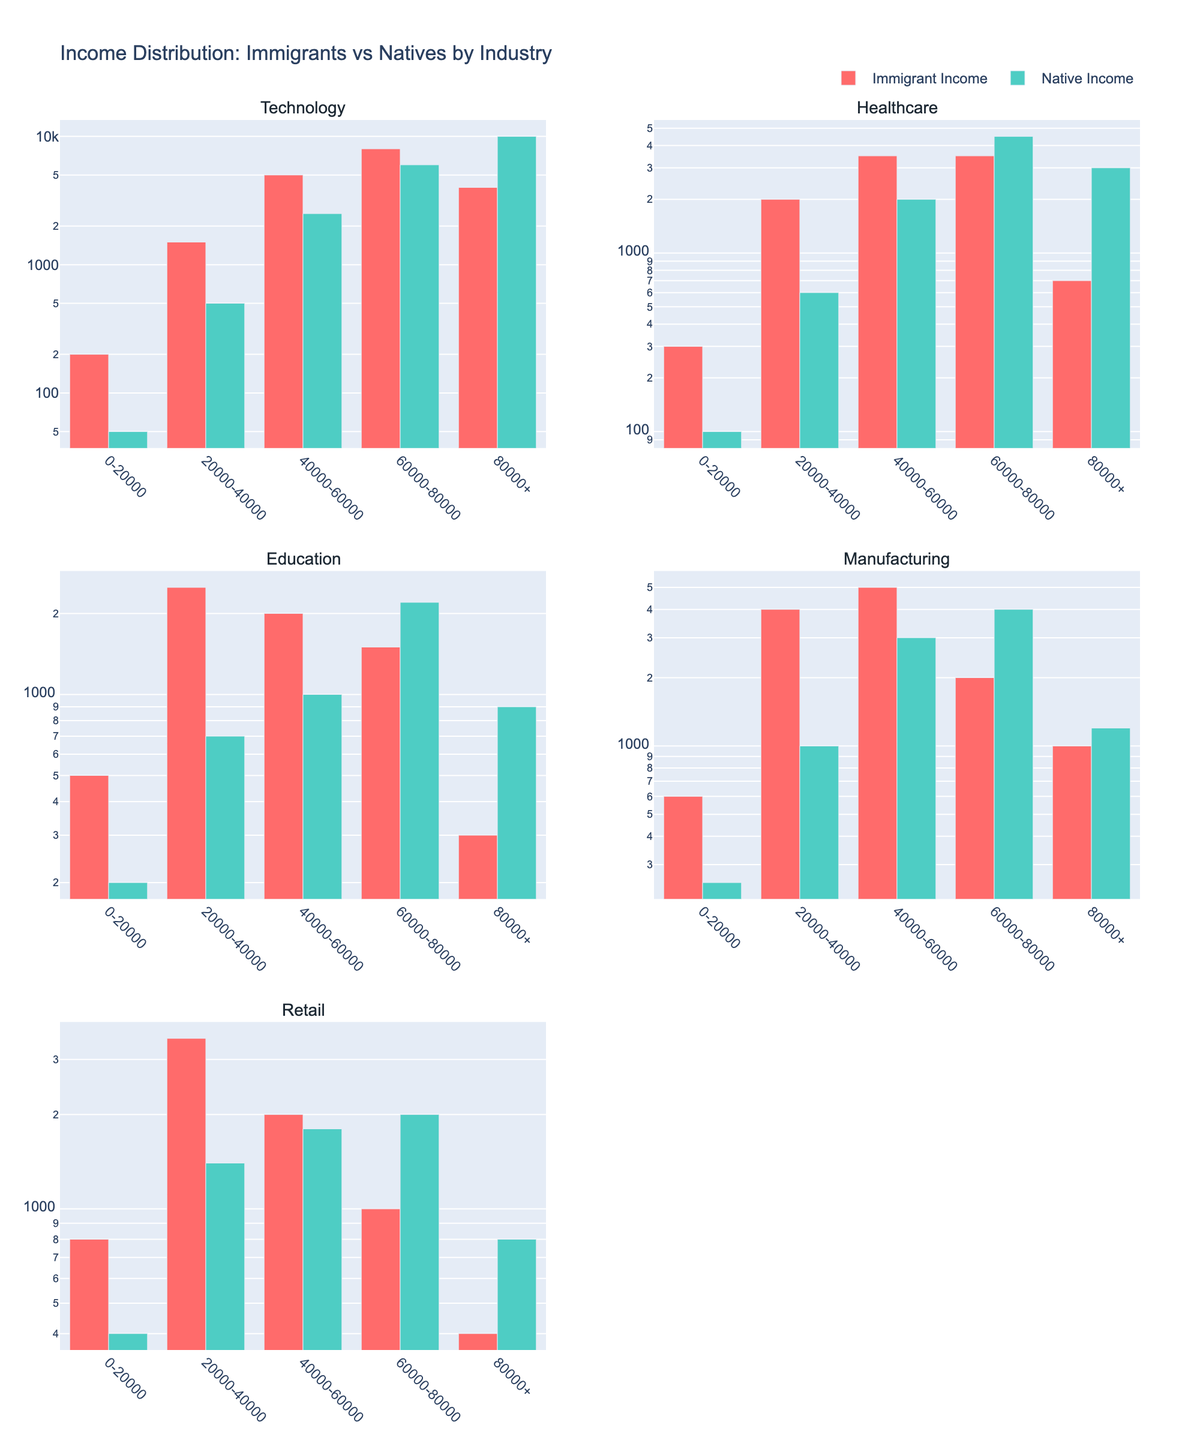What's the title of the figure? The title of the figure is located at the top-center of the plot. It reads "Income Distribution: Immigrants vs Natives by Industry", which is straightforward to find because of its prominent placement.
Answer: "Income Distribution: Immigrants vs Natives by Industry" How does the immigrant income compare to native income in the 80000+ segment for the Technology industry? The subplot for the Technology industry shows two bars for the 80000+ income segment. The bar for Immigrant Income is lower than the bar for Native Income. Specifically, the Immigrant Income is 4000, while the Native Income is 10000.
Answer: Immigrant Income is 4000, Native Income is 10000 What is the income segment with the highest income for immigrants in Healthcare, and how much is it? In the Healthcare subplot, check for the tallest bar in the Immigrant Income categories. The highest is the 20000-40000 segment, with an income of 2000.
Answer: 20000-40000 income segment, 2000 Which industry has the closest immigrant and native income distributions for the 0-20000 segment? By comparing the height of bars for Immigrant and Native Income in the 0-20000 segments across all subplots, you can see that Healthcare has the closest distribution with 300 vs 100 units.
Answer: Healthcare What is the difference between immigrant and native incomes in the 60000-80000 segment of the Retail industry? Check the heights of the two bars for the 60000-80000 segment in the Retail industry subplot. The bars for Immigrant Income and Native Income are at 1000 and 2000, respectively. The difference is 2000 - 1000 = 1000.
Answer: 1000 In which segments do native incomes exceed immigrant incomes for the Manufacturing industry? In the Manufacturing subplot, compare the heights of bars for each income segment. Native incomes exceed immigrant incomes in the 60000-80000 and the 80000+ segments.
Answer: 60000-80000 and 80000+ segments For the Education industry, which income segment shows the least difference between immigrant and native incomes? Find the income segment with the smallest gap between the bars for Immigrant and Native Income in the Education subplot. The 40000-60000 segment has the smallest difference (2000 vs 1000).
Answer: 40000-60000 segment Comparing the Technology and Retail industries, which one has a higher immigrant income in the 40000-60000 segment? Look at the height of the bars for Immigrant Income in the 40000-60000 segments of the Technology and Retail subplots. The Technology industry bar reaches 5000, while the Retail industry bar reaches 2000. Thus, Technology has a higher immigrant income in this segment.
Answer: Technology What overall trend can you observe in the income distribution of immigrants across different industries? Observing the subplots, you can see that the income distributions vary, but generally, immigrant incomes are lower than native incomes in higher segments, with discrepancies being more pronounced in high-income segments across most industries. However, in many lower and mid-income segments, immigrant incomes are often comparable or sometimes higher than native incomes.
Answer: Immigrant incomes generally lower in higher segments, more comparable in lower and mid segments For the Healthcare industry, which income segment shows an equal income distribution between immigrants and natives? In the Healthcare subplot, identify the income segment where the heights of the Immigrant and Native Income bars are similar. The 60000-80000 segment shows nearly equal income distributions, with both at 3500 and 4500 close enough to be considered almost equal.
Answer: 60000-80000 segment 